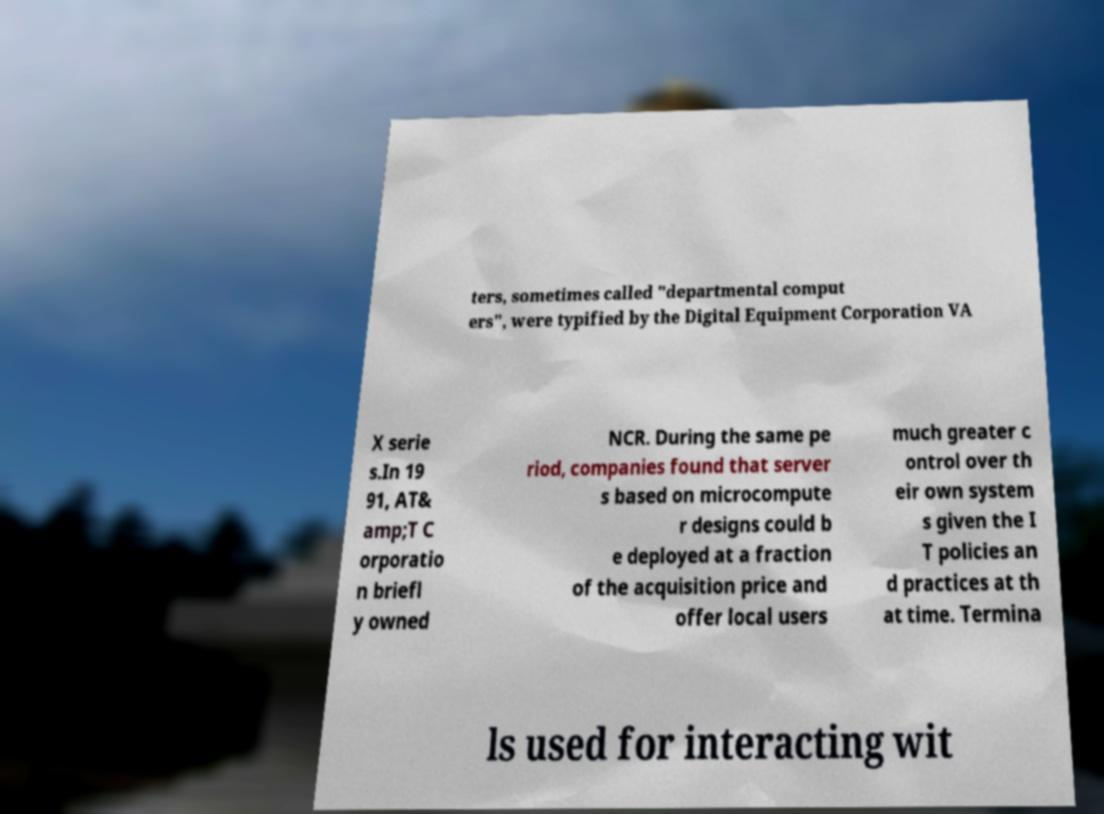Could you extract and type out the text from this image? ters, sometimes called "departmental comput ers", were typified by the Digital Equipment Corporation VA X serie s.In 19 91, AT& amp;T C orporatio n briefl y owned NCR. During the same pe riod, companies found that server s based on microcompute r designs could b e deployed at a fraction of the acquisition price and offer local users much greater c ontrol over th eir own system s given the I T policies an d practices at th at time. Termina ls used for interacting wit 